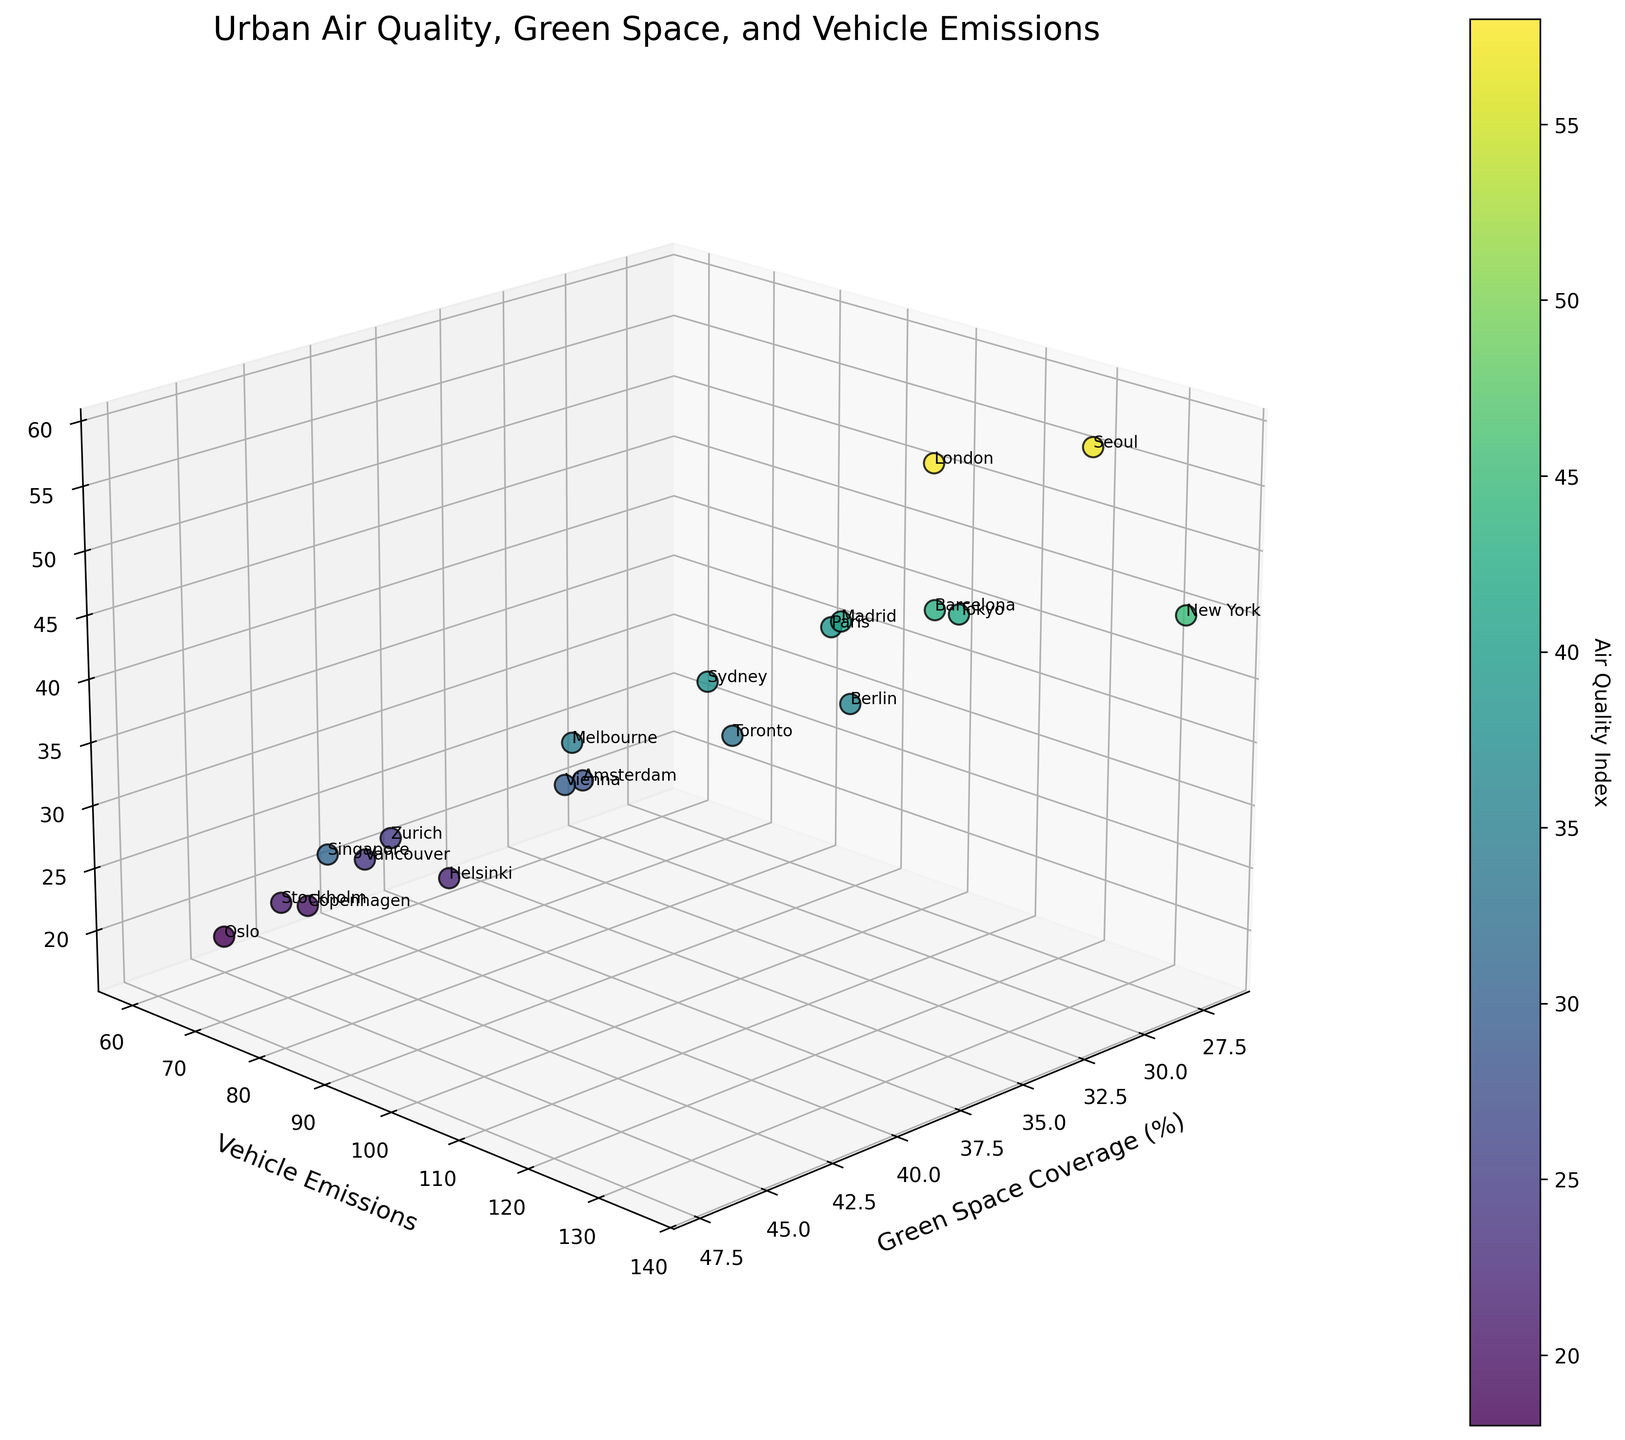What's the title of the figure? The title is prominently displayed at the top of the figure.
Answer: Urban Air Quality, Green Space, and Vehicle Emissions How many data points are there in the figure? Count the number of distinct points scattered across the 3D plot. Each point represents a city.
Answer: 19 Which city has the highest Air Quality Index? Look for the point with the highest Z-value, denoted as Air Quality Index, and read the city label next to it.
Answer: London What is the approximate Green Space Coverage for Oslo compared to Sydney? First, identify the points labeled as Oslo and Sydney. Then, compare their Green Space Coverage values shown on the x-axis.
Answer: Oslo: 45%, Sydney: 35% Which city has the lowest Vehicle Emissions and what is its Air Quality Index? Look for the point with the lowest Y-value, denoted as Vehicle Emissions, and check the corresponding Z-value for the Air Quality Index.
Answer: Oslo: 60, Air Quality Index: 18 Is there a general trend between Vehicle Emissions and Air Quality Index? Observe if there's a visible pattern in the scatter plot, such as whether higher Vehicle Emissions correlate with higher or lower Air Quality Indices.
Answer: Higher Vehicle Emissions generally correlate with higher Air Quality Index Which city has the highest Green Space Coverage, and what is its Air Quality Index? Look for the point with the highest X-value, denoted as Green Space Coverage, and find its corresponding Z-value for the Air Quality Index.
Answer: Singapore: Green Space Coverage: 47%, Air Quality Index: 31 Do cities with higher Green Space Coverage tend to have lower Vehicle Emissions? Examine the distribution of points with higher Green Space Coverage values and observe their corresponding Vehicle Emissions values on the y-axis.
Answer: Generally, yes Which two cities have the closest values for all three variables? Compare the proximity of points in the 3D space by their coordinates (Green Space Coverage, Vehicle Emissions, and Air Quality Index).
Answer: Zurich and Vancouver What is the difference in Air Quality Index between Vancouver and Paris? Locate the data points for Vancouver and Paris, note their Air Quality Index values, and calculate the difference: Vancouver (24) and Paris (39).
Answer: 15 